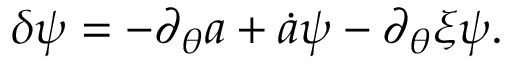<formula> <loc_0><loc_0><loc_500><loc_500>\delta \psi = - \partial _ { \theta } a + \dot { a } \psi - \partial _ { \theta } \xi \psi .</formula> 